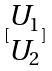Convert formula to latex. <formula><loc_0><loc_0><loc_500><loc_500>[ \begin{matrix} U _ { 1 } \\ U _ { 2 } \end{matrix} ]</formula> 